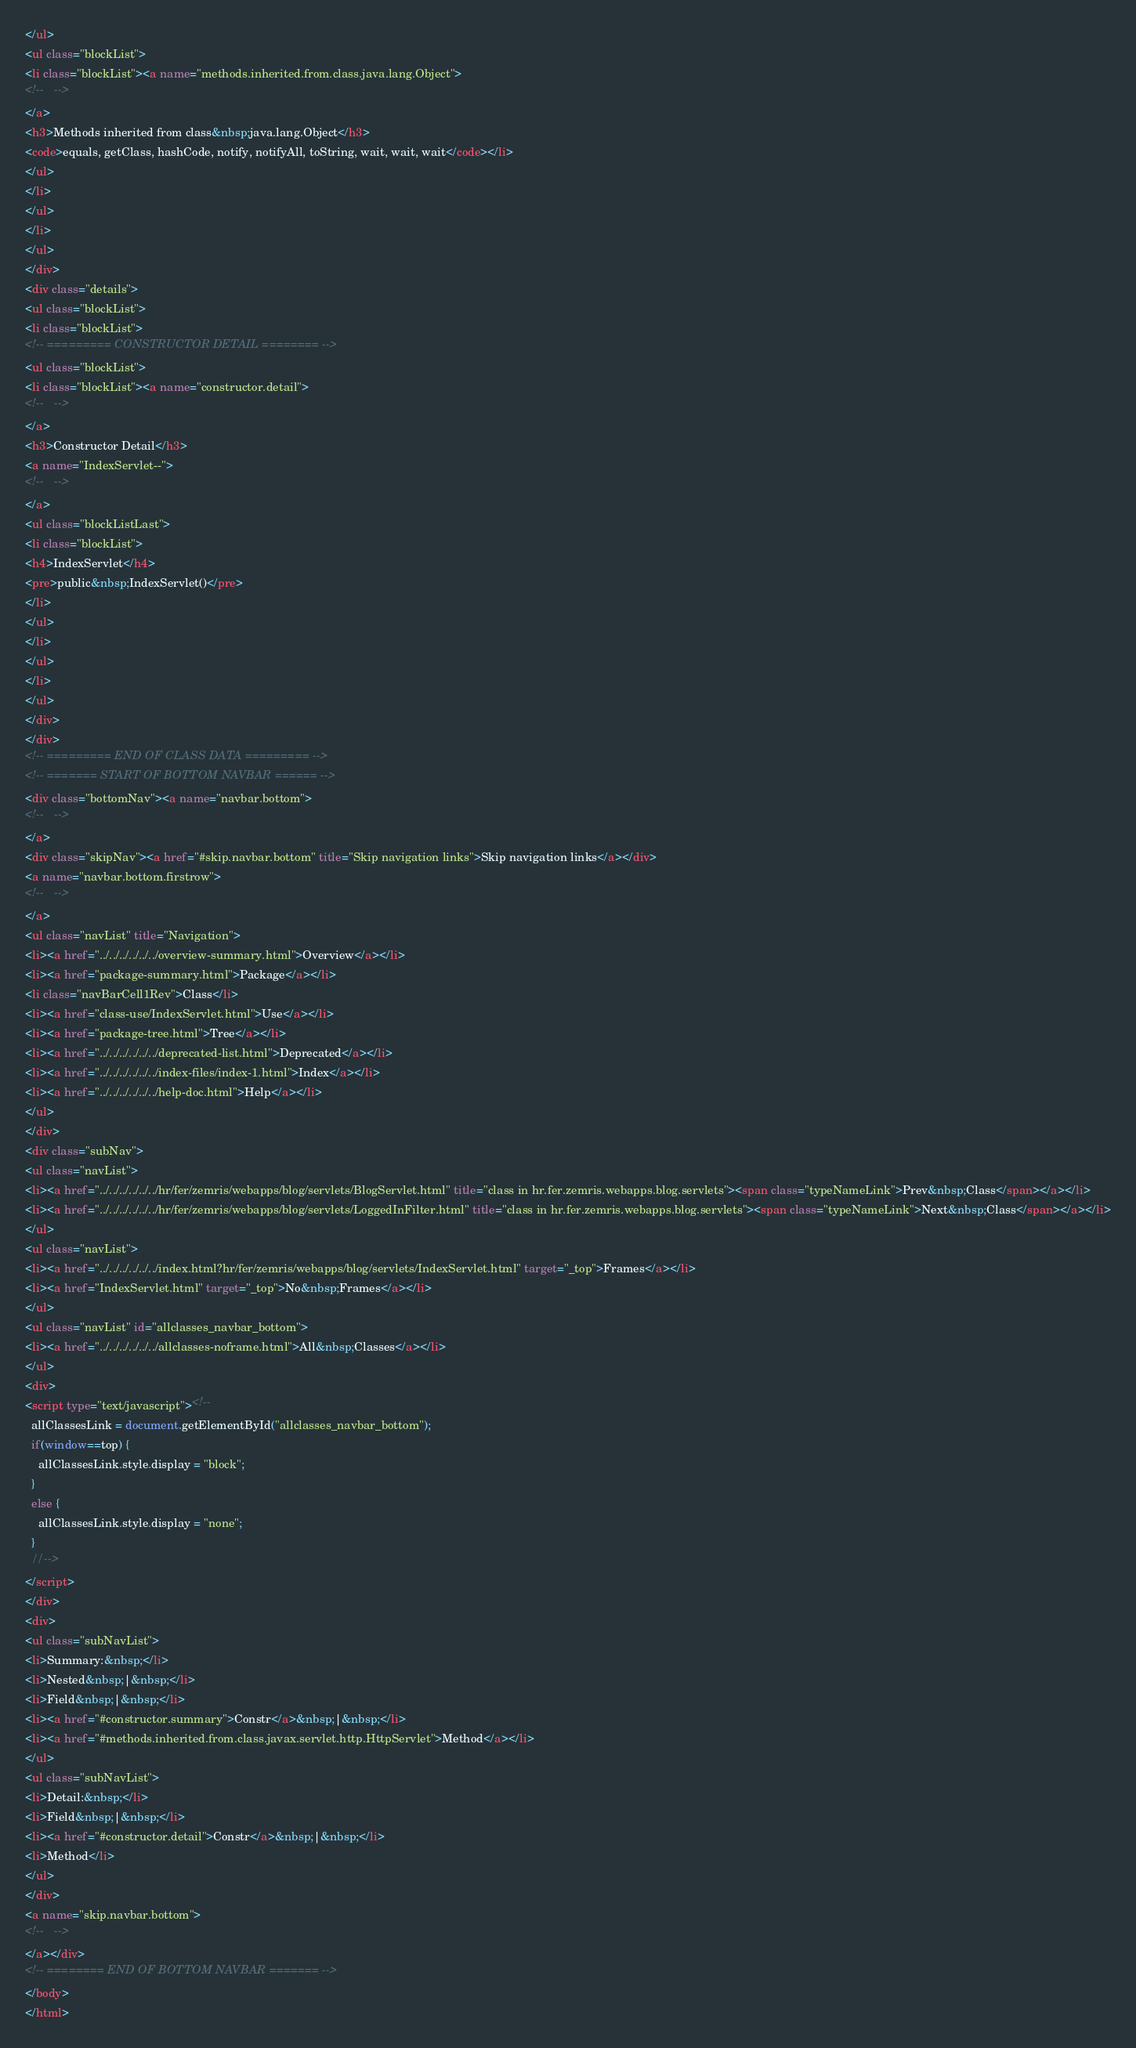Convert code to text. <code><loc_0><loc_0><loc_500><loc_500><_HTML_></ul>
<ul class="blockList">
<li class="blockList"><a name="methods.inherited.from.class.java.lang.Object">
<!--   -->
</a>
<h3>Methods inherited from class&nbsp;java.lang.Object</h3>
<code>equals, getClass, hashCode, notify, notifyAll, toString, wait, wait, wait</code></li>
</ul>
</li>
</ul>
</li>
</ul>
</div>
<div class="details">
<ul class="blockList">
<li class="blockList">
<!-- ========= CONSTRUCTOR DETAIL ======== -->
<ul class="blockList">
<li class="blockList"><a name="constructor.detail">
<!--   -->
</a>
<h3>Constructor Detail</h3>
<a name="IndexServlet--">
<!--   -->
</a>
<ul class="blockListLast">
<li class="blockList">
<h4>IndexServlet</h4>
<pre>public&nbsp;IndexServlet()</pre>
</li>
</ul>
</li>
</ul>
</li>
</ul>
</div>
</div>
<!-- ========= END OF CLASS DATA ========= -->
<!-- ======= START OF BOTTOM NAVBAR ====== -->
<div class="bottomNav"><a name="navbar.bottom">
<!--   -->
</a>
<div class="skipNav"><a href="#skip.navbar.bottom" title="Skip navigation links">Skip navigation links</a></div>
<a name="navbar.bottom.firstrow">
<!--   -->
</a>
<ul class="navList" title="Navigation">
<li><a href="../../../../../../overview-summary.html">Overview</a></li>
<li><a href="package-summary.html">Package</a></li>
<li class="navBarCell1Rev">Class</li>
<li><a href="class-use/IndexServlet.html">Use</a></li>
<li><a href="package-tree.html">Tree</a></li>
<li><a href="../../../../../../deprecated-list.html">Deprecated</a></li>
<li><a href="../../../../../../index-files/index-1.html">Index</a></li>
<li><a href="../../../../../../help-doc.html">Help</a></li>
</ul>
</div>
<div class="subNav">
<ul class="navList">
<li><a href="../../../../../../hr/fer/zemris/webapps/blog/servlets/BlogServlet.html" title="class in hr.fer.zemris.webapps.blog.servlets"><span class="typeNameLink">Prev&nbsp;Class</span></a></li>
<li><a href="../../../../../../hr/fer/zemris/webapps/blog/servlets/LoggedInFilter.html" title="class in hr.fer.zemris.webapps.blog.servlets"><span class="typeNameLink">Next&nbsp;Class</span></a></li>
</ul>
<ul class="navList">
<li><a href="../../../../../../index.html?hr/fer/zemris/webapps/blog/servlets/IndexServlet.html" target="_top">Frames</a></li>
<li><a href="IndexServlet.html" target="_top">No&nbsp;Frames</a></li>
</ul>
<ul class="navList" id="allclasses_navbar_bottom">
<li><a href="../../../../../../allclasses-noframe.html">All&nbsp;Classes</a></li>
</ul>
<div>
<script type="text/javascript"><!--
  allClassesLink = document.getElementById("allclasses_navbar_bottom");
  if(window==top) {
    allClassesLink.style.display = "block";
  }
  else {
    allClassesLink.style.display = "none";
  }
  //-->
</script>
</div>
<div>
<ul class="subNavList">
<li>Summary:&nbsp;</li>
<li>Nested&nbsp;|&nbsp;</li>
<li>Field&nbsp;|&nbsp;</li>
<li><a href="#constructor.summary">Constr</a>&nbsp;|&nbsp;</li>
<li><a href="#methods.inherited.from.class.javax.servlet.http.HttpServlet">Method</a></li>
</ul>
<ul class="subNavList">
<li>Detail:&nbsp;</li>
<li>Field&nbsp;|&nbsp;</li>
<li><a href="#constructor.detail">Constr</a>&nbsp;|&nbsp;</li>
<li>Method</li>
</ul>
</div>
<a name="skip.navbar.bottom">
<!--   -->
</a></div>
<!-- ======== END OF BOTTOM NAVBAR ======= -->
</body>
</html>
</code> 